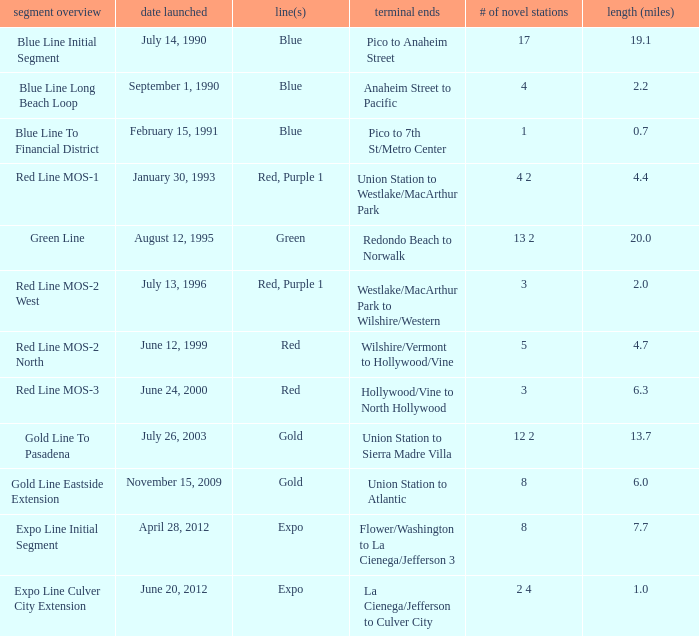What date of segment description red line mos-2 north open? June 12, 1999. 